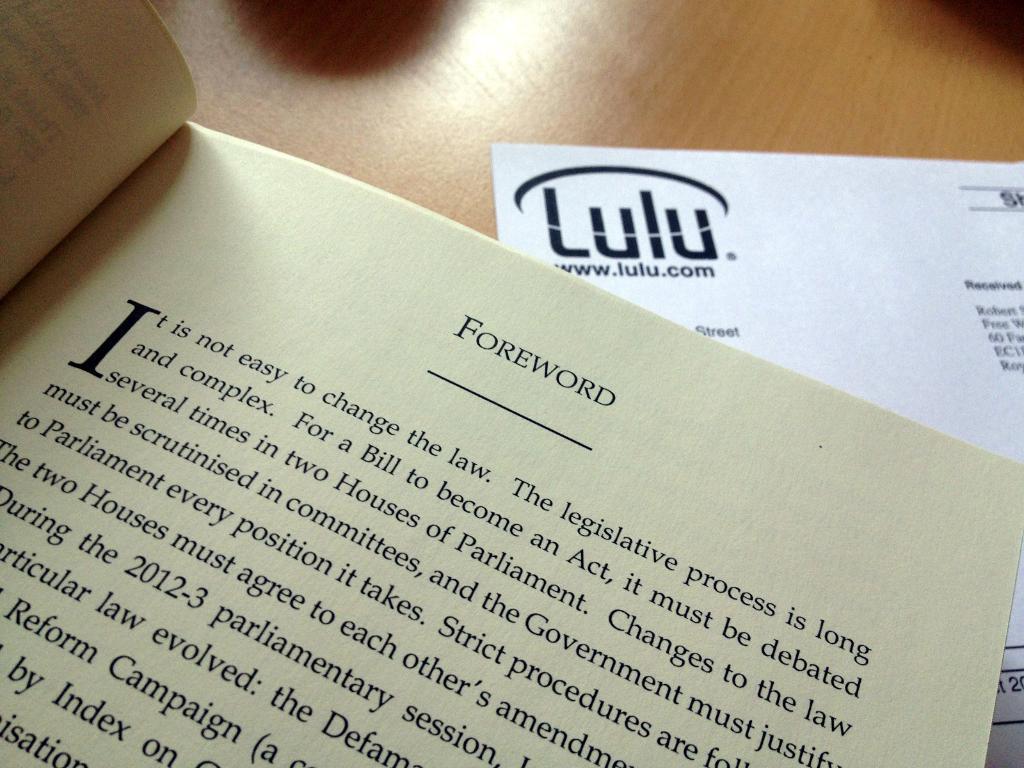Could you give a brief overview of what you see in this image? In this image, we can see a book, a paper and some shadows on the table. 